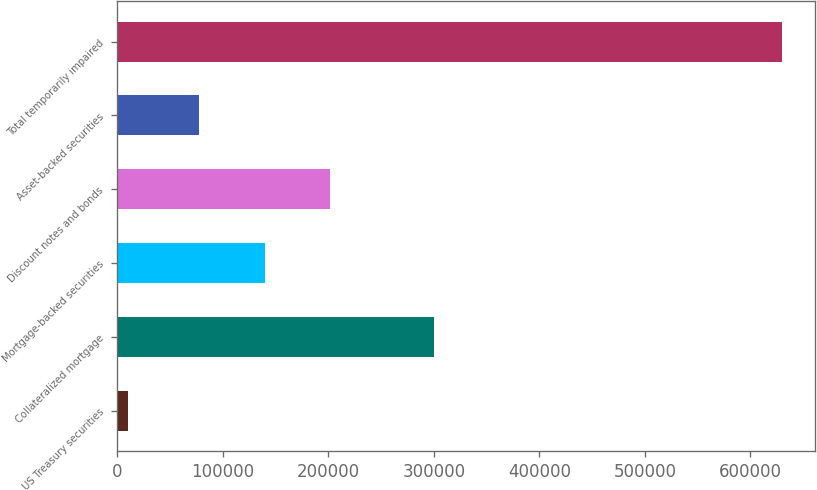Convert chart. <chart><loc_0><loc_0><loc_500><loc_500><bar_chart><fcel>US Treasury securities<fcel>Collateralized mortgage<fcel>Mortgage-backed securities<fcel>Discount notes and bonds<fcel>Asset-backed securities<fcel>Total temporarily impaired<nl><fcel>9878<fcel>299827<fcel>139773<fcel>201764<fcel>77782<fcel>629788<nl></chart> 